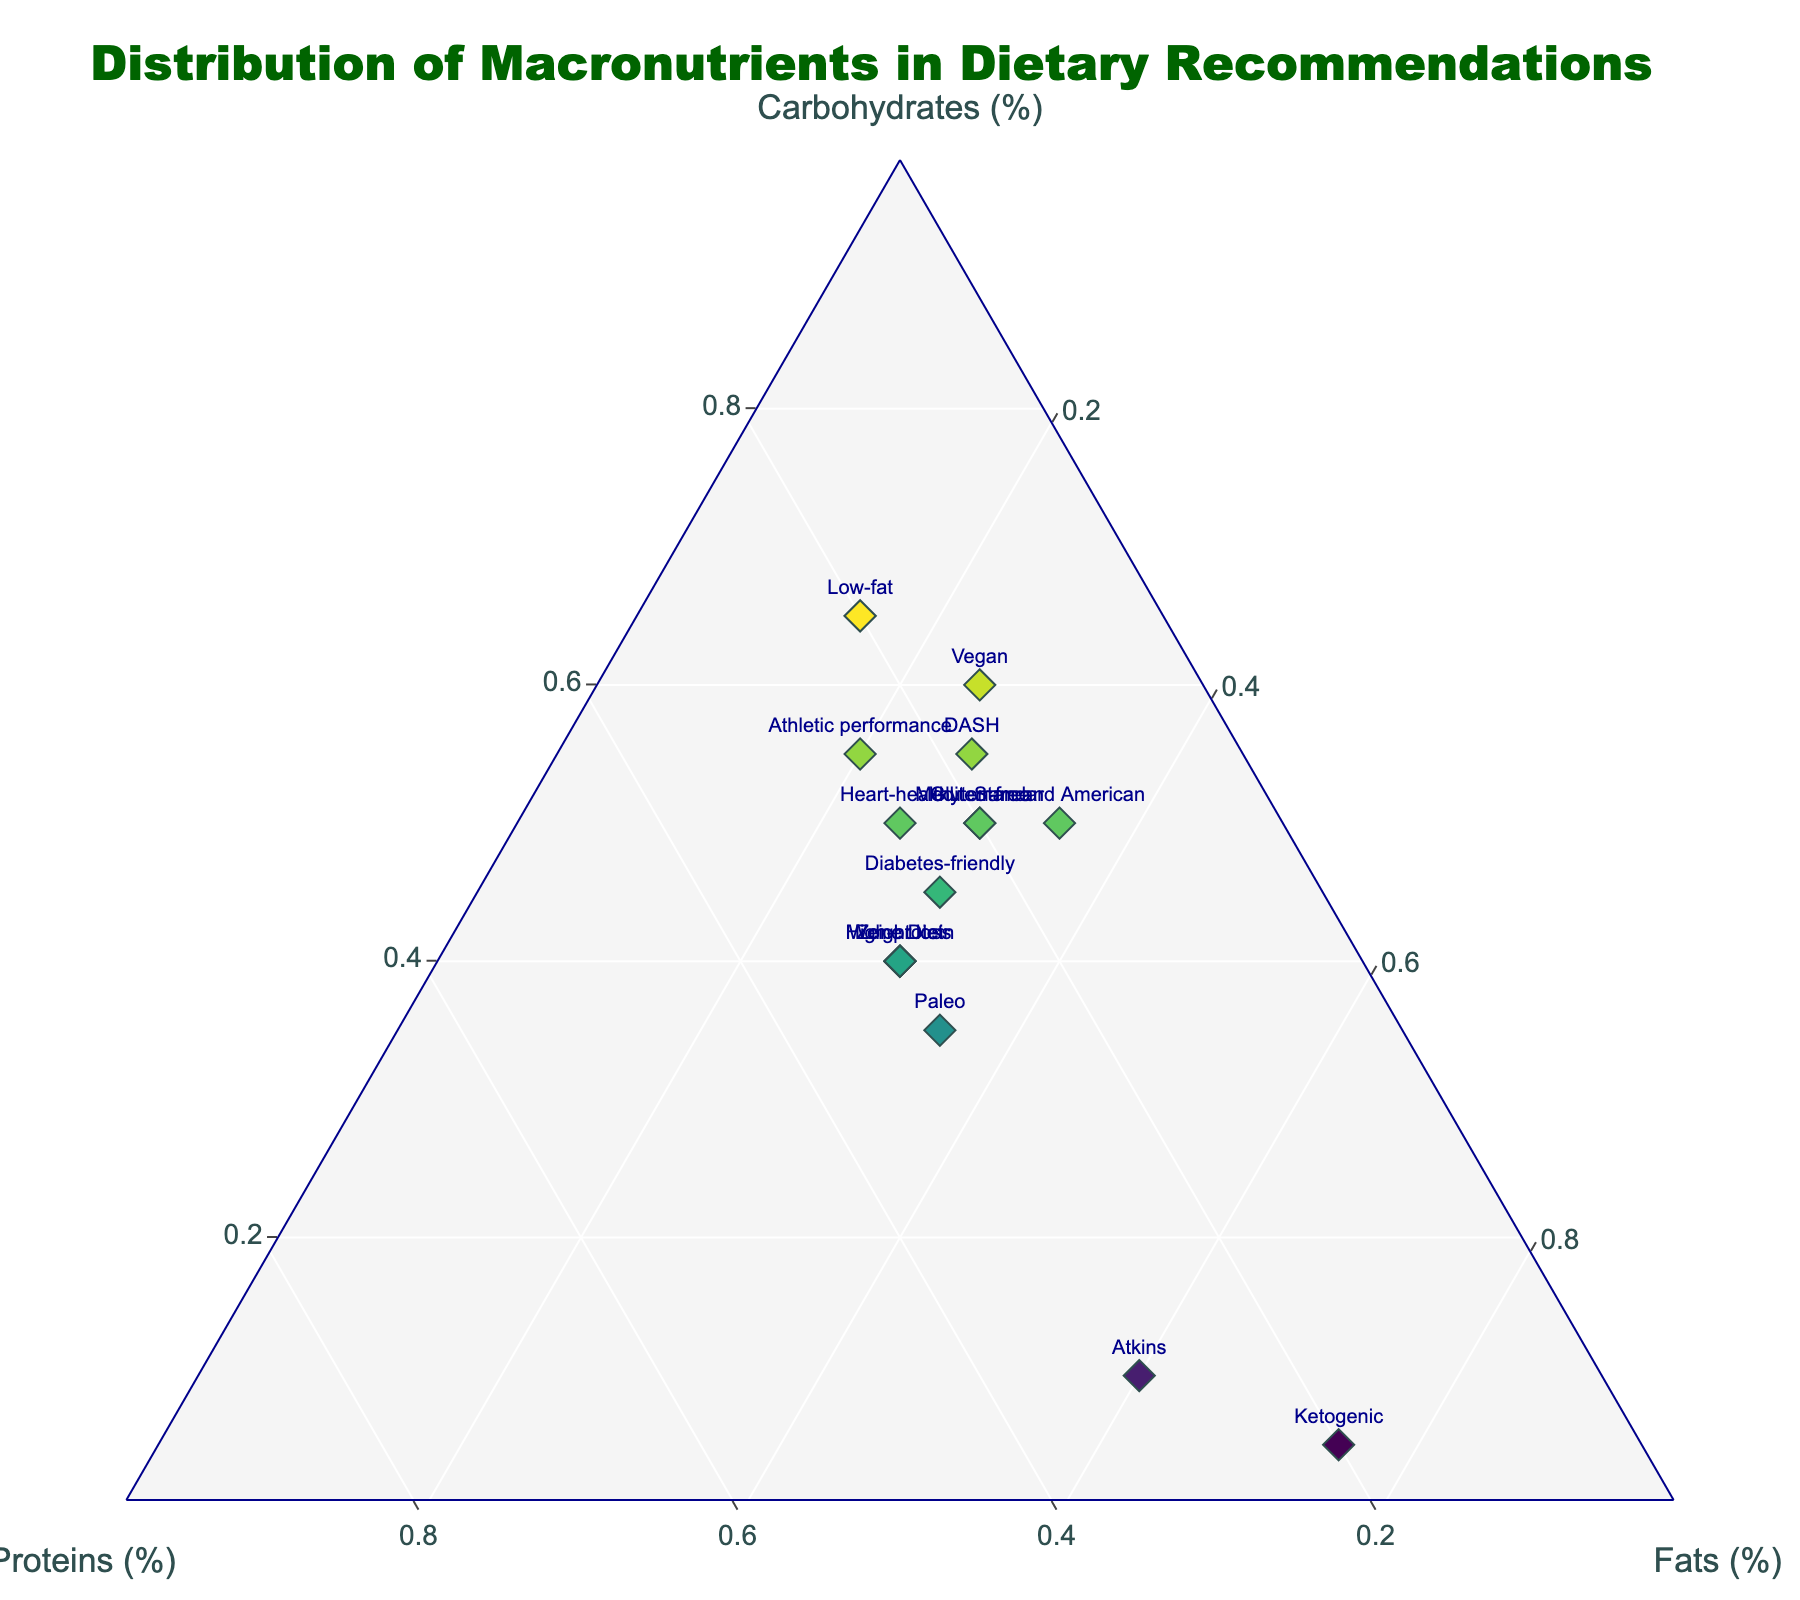Which diet has the highest proportion of fats? The diet with the highest proportion of fats is the one with the highest value on the fats axis, which is the ketogenic diet at 75%.
Answer: Ketogenic What is the range of protein percentages across all diets? To find the range, identify the highest and lowest values in the proteins category. The values are 15% (Vegan and Standard American) to 30% (Zone Diet, Paleo, Atkins, High-protein, Weight loss), so the range is 30% - 15% = 15%.
Answer: 15% Which diets have an equal distribution of macronutrients (proteins, fats, and carbohydrates)? The diets with equal distribution have the same or very close values for proteins, fats, and carbohydrates. By looking at the plot, the Zone Diet, High-protein Diet, and Weight Loss Diet each have roughly equal proportions of around 30% for each macronutrient.
Answer: Zone Diet, High-protein, Weight loss How do the carbohydrate proportions of the DASH and Mediterranean diets compare? Compare the carbohydrate percentages of the DASH (55%) and Mediterranean (50%) diets. DASH contains 5% more carbohydrates.
Answer: DASH has more Which diet has the highest protein proportion? Look for the diet with the highest value on the proteins axis. The highest protein proportion (30%) is found in the Zone Diet, Paleo Diet, Atkins Diet, High-protein Diet, and Weight Loss Diet.
Answer: Zone Diet, Paleo, Atkins, High-protein, Weight loss Among the Heart-healthy and the Diabetes-friendly diets, which one has higher fat content? The Heart-healthy diet has 25% fats and the Diabetes-friendly diet has 30% fats. Hence, the Diabetes-friendly diet has higher fat content.
Answer: Diabetes-friendly What is the sum of the protein percentages in the Vegan and Standard American diets? The Vegan diet has 15% proteins and the Standard American diet has 15% proteins. Sum is 15% + 15% = 30%.
Answer: 30% Which diets contain exactly 20% proteins? Based on the plot, Mediterranean, Ketogenic, Low-fat, and Gluten-free diets each contain exactly 20% proteins.
Answer: Mediterranean, Ketogenic, Low-fat, Gluten-free Which diet has the lowest proportion of carbohydrates? Determine the diet that falls closest to the origin along the carbohydrate axis. The Ketogenic diet has the lowest carbohydrate proportion at 5%.
Answer: Ketogenic How do the fat proportions in the Atkins and Standard American diets compare? The Atkins diet has 60% fats and the Standard American diet has 35% fats. Therefore, the Atkins diet has 25% more fats than the Standard American diet.
Answer: Atkins has more 